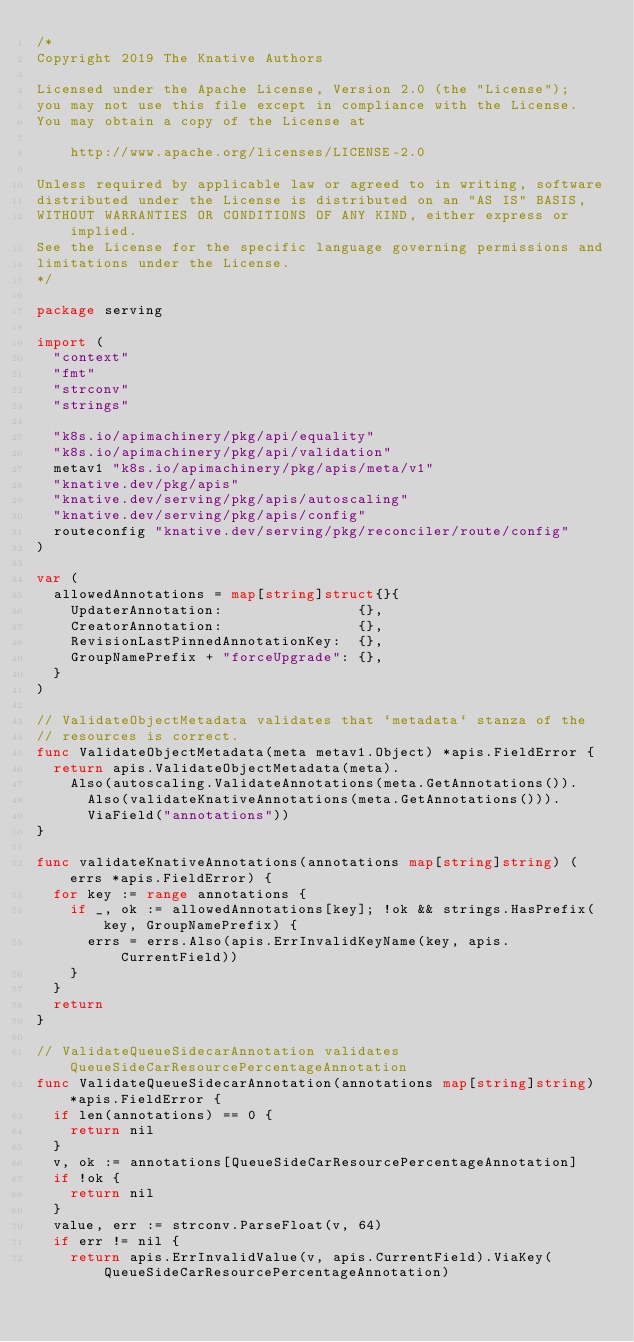<code> <loc_0><loc_0><loc_500><loc_500><_Go_>/*
Copyright 2019 The Knative Authors

Licensed under the Apache License, Version 2.0 (the "License");
you may not use this file except in compliance with the License.
You may obtain a copy of the License at

    http://www.apache.org/licenses/LICENSE-2.0

Unless required by applicable law or agreed to in writing, software
distributed under the License is distributed on an "AS IS" BASIS,
WITHOUT WARRANTIES OR CONDITIONS OF ANY KIND, either express or implied.
See the License for the specific language governing permissions and
limitations under the License.
*/

package serving

import (
	"context"
	"fmt"
	"strconv"
	"strings"

	"k8s.io/apimachinery/pkg/api/equality"
	"k8s.io/apimachinery/pkg/api/validation"
	metav1 "k8s.io/apimachinery/pkg/apis/meta/v1"
	"knative.dev/pkg/apis"
	"knative.dev/serving/pkg/apis/autoscaling"
	"knative.dev/serving/pkg/apis/config"
	routeconfig "knative.dev/serving/pkg/reconciler/route/config"
)

var (
	allowedAnnotations = map[string]struct{}{
		UpdaterAnnotation:                {},
		CreatorAnnotation:                {},
		RevisionLastPinnedAnnotationKey:  {},
		GroupNamePrefix + "forceUpgrade": {},
	}
)

// ValidateObjectMetadata validates that `metadata` stanza of the
// resources is correct.
func ValidateObjectMetadata(meta metav1.Object) *apis.FieldError {
	return apis.ValidateObjectMetadata(meta).
		Also(autoscaling.ValidateAnnotations(meta.GetAnnotations()).
			Also(validateKnativeAnnotations(meta.GetAnnotations())).
			ViaField("annotations"))
}

func validateKnativeAnnotations(annotations map[string]string) (errs *apis.FieldError) {
	for key := range annotations {
		if _, ok := allowedAnnotations[key]; !ok && strings.HasPrefix(key, GroupNamePrefix) {
			errs = errs.Also(apis.ErrInvalidKeyName(key, apis.CurrentField))
		}
	}
	return
}

// ValidateQueueSidecarAnnotation validates QueueSideCarResourcePercentageAnnotation
func ValidateQueueSidecarAnnotation(annotations map[string]string) *apis.FieldError {
	if len(annotations) == 0 {
		return nil
	}
	v, ok := annotations[QueueSideCarResourcePercentageAnnotation]
	if !ok {
		return nil
	}
	value, err := strconv.ParseFloat(v, 64)
	if err != nil {
		return apis.ErrInvalidValue(v, apis.CurrentField).ViaKey(QueueSideCarResourcePercentageAnnotation)</code> 